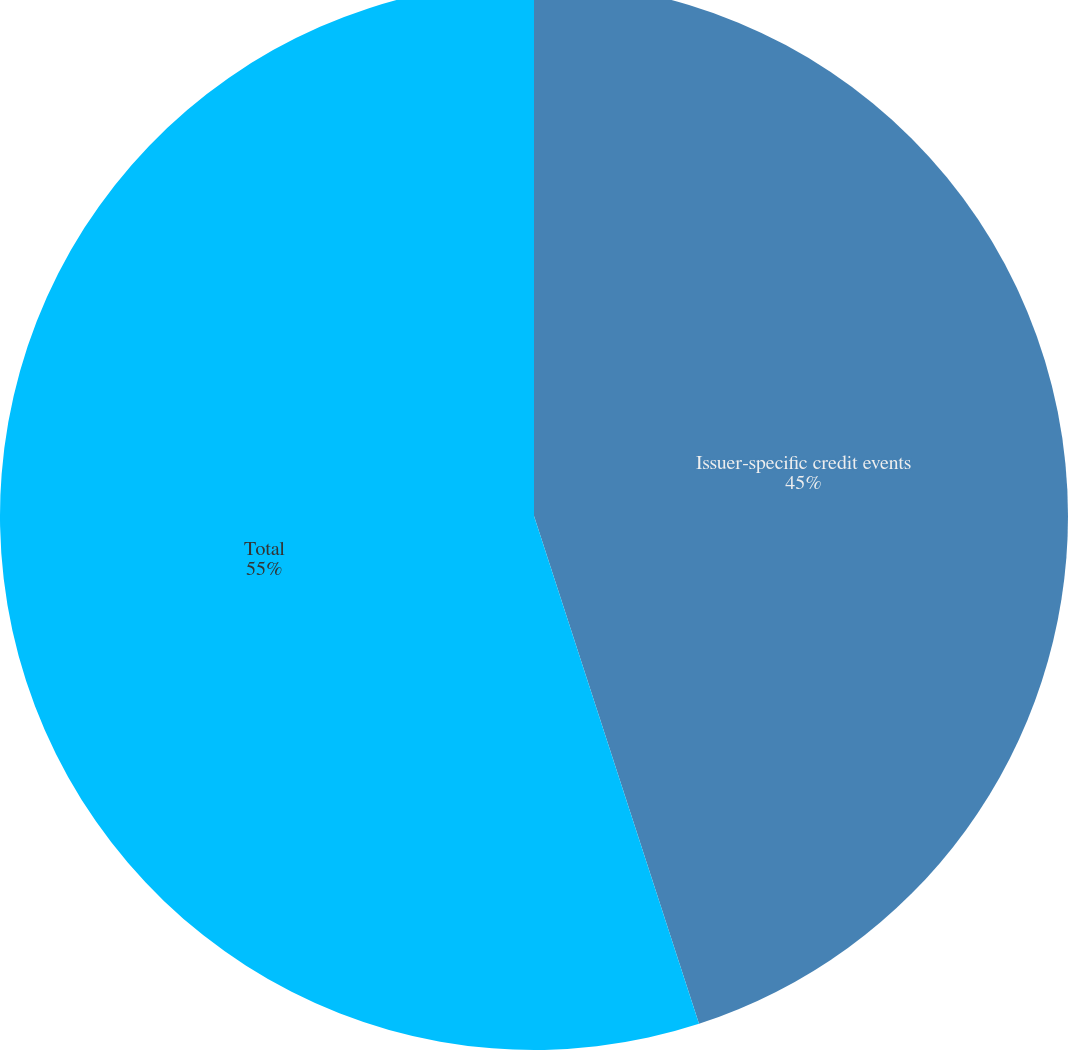<chart> <loc_0><loc_0><loc_500><loc_500><pie_chart><fcel>Issuer-specific credit events<fcel>Total<nl><fcel>45.0%<fcel>55.0%<nl></chart> 